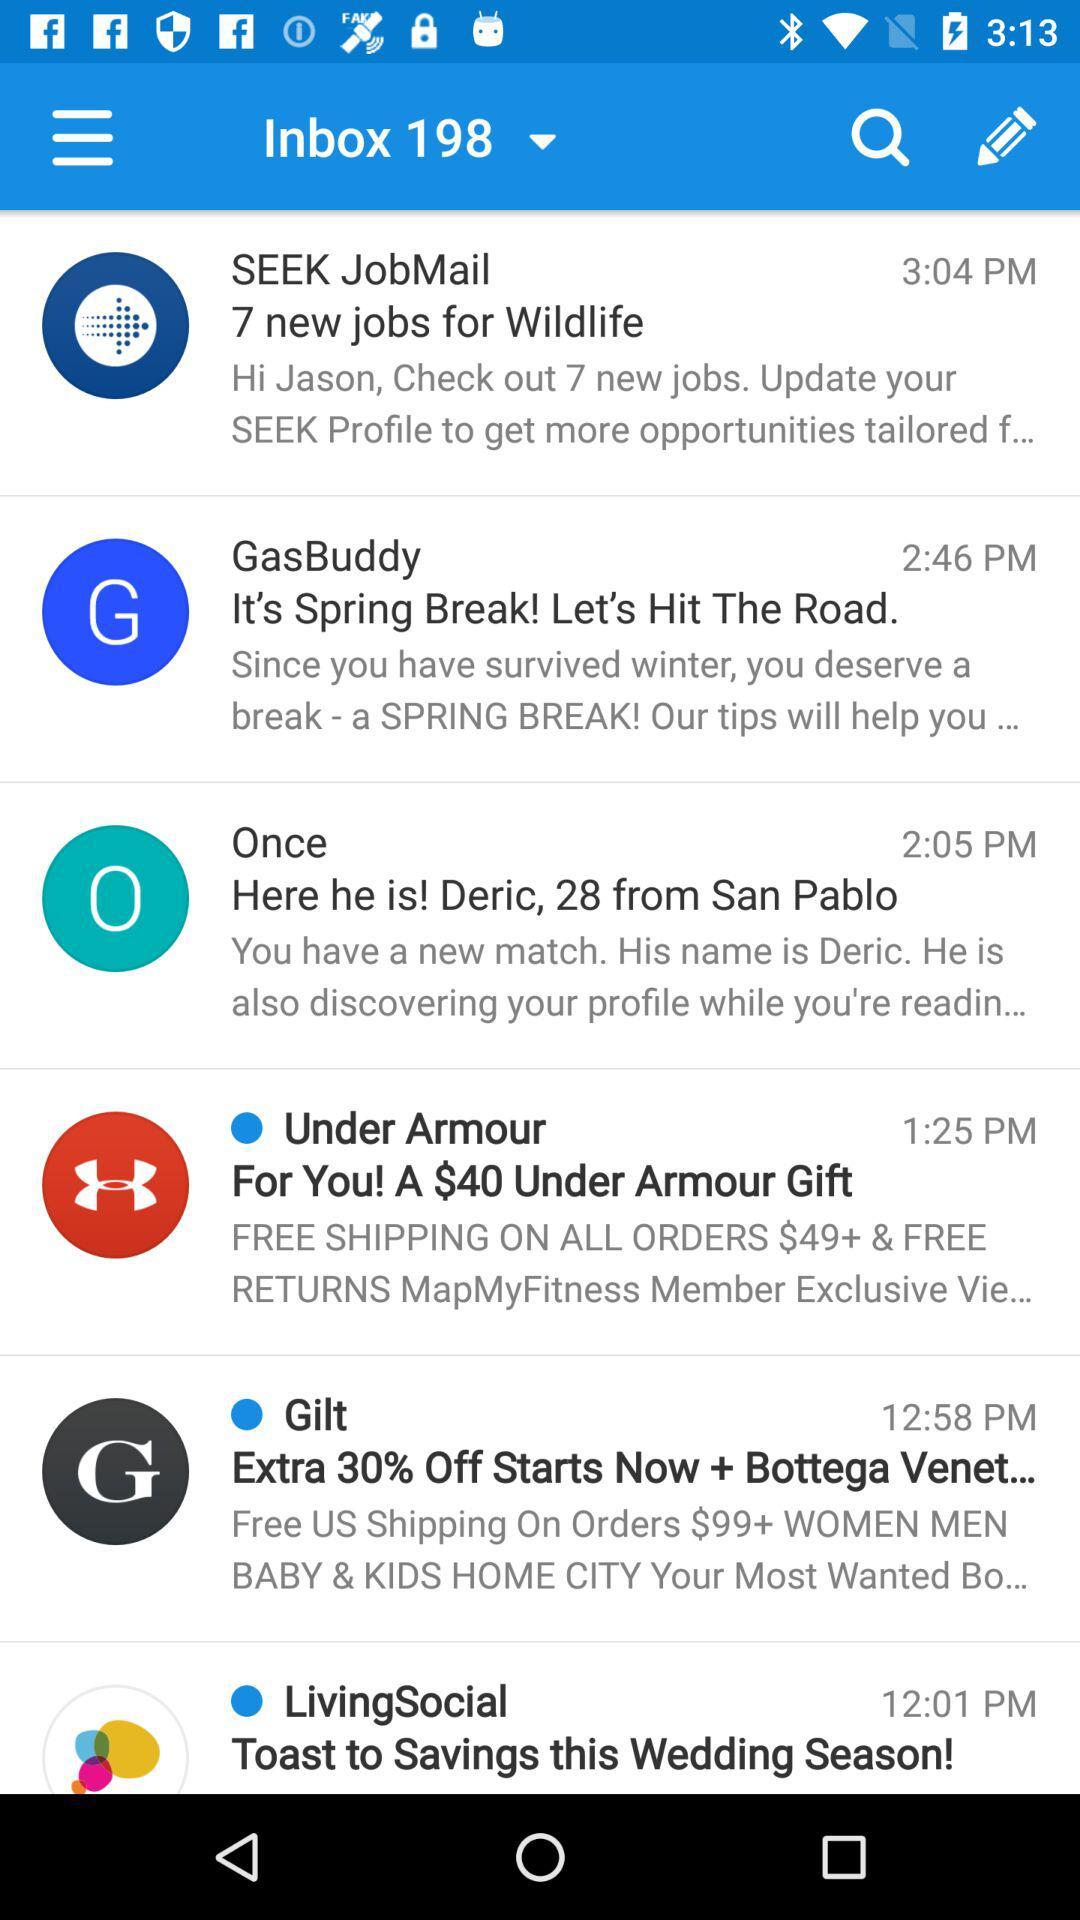At what time does the mail "Once" arrive? The mail arrives at 2:05 PM. 